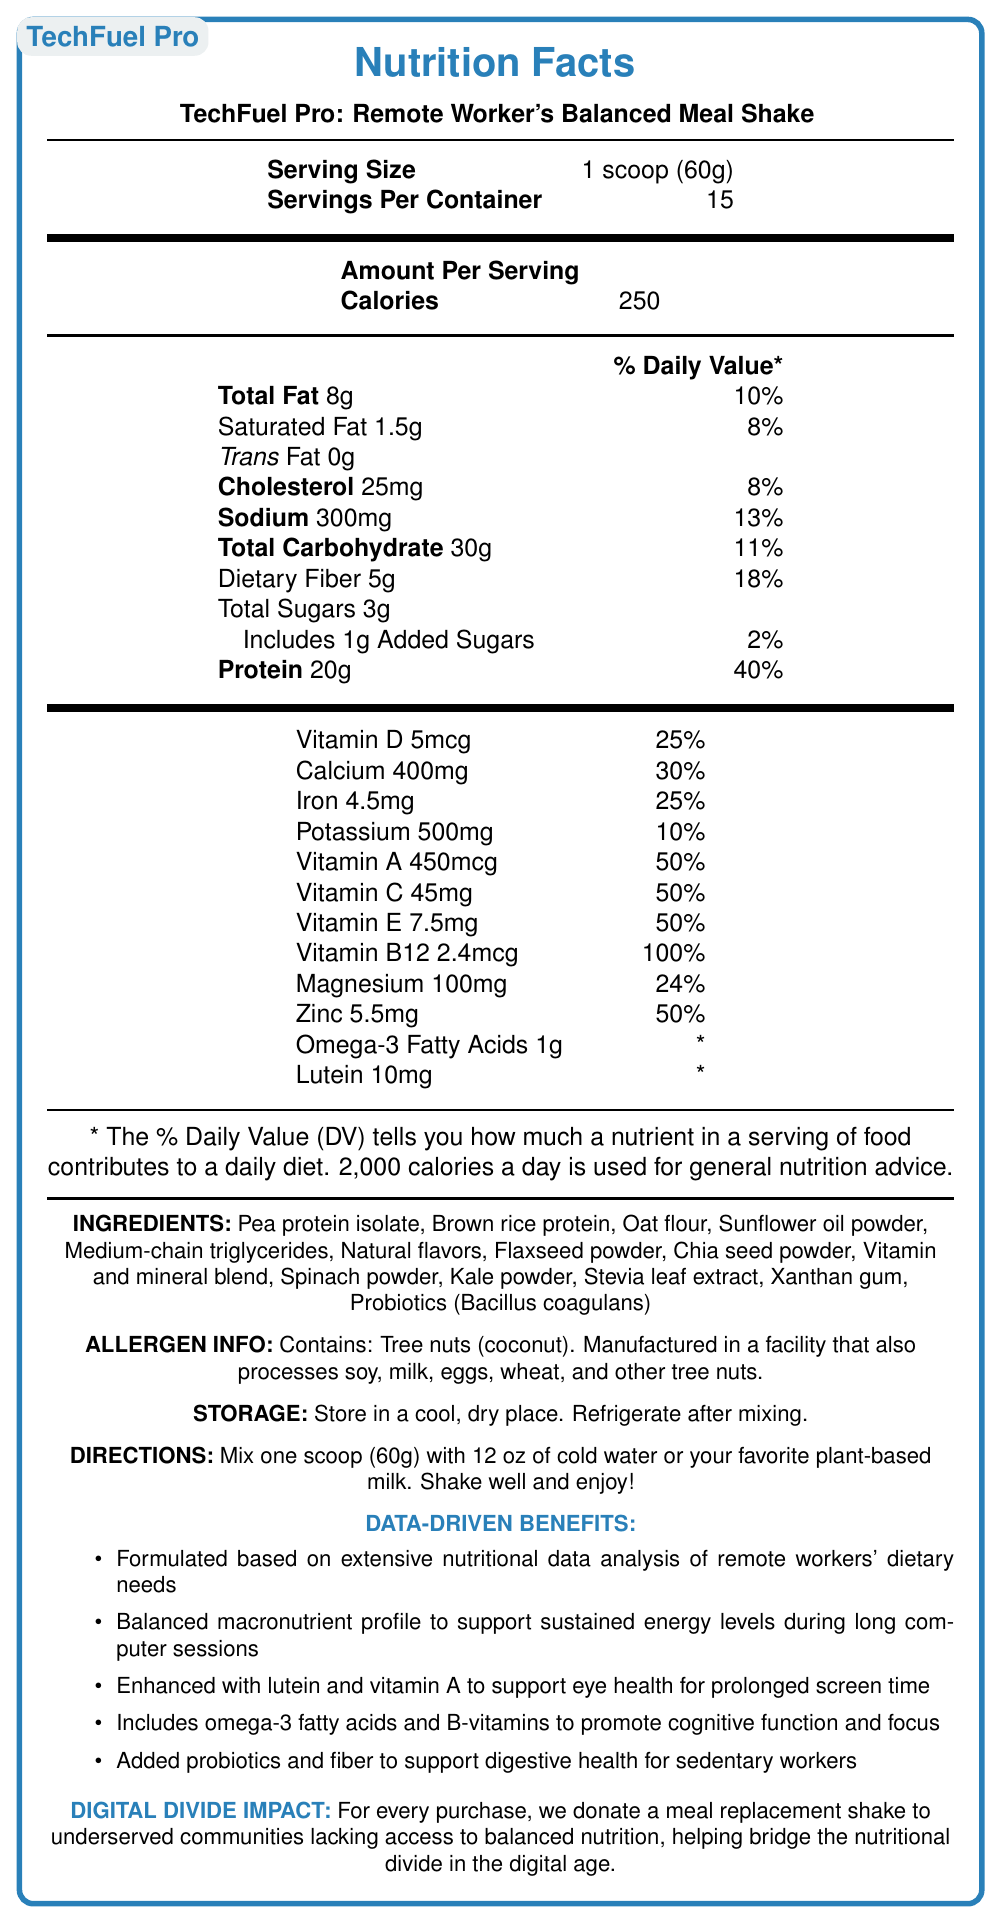what is the serving size? The document explicitly states the serving size as 1 scoop (60g) in the Nutrition Facts section.
Answer: 1 scoop (60g) how many calories per serving? The document lists the number of calories per serving as 250 in the Amount Per Serving section.
Answer: 250 how much protein is in one serving? According to the document, one serving contains 20g of protein and is 40% of the Daily Value.
Answer: 20g what is the percentage of daily value for dietary fiber? The document specifies that the daily value percentage for dietary fiber is 18%.
Answer: 18% which vitamin has the highest percentage of daily value per serving? Vitamin B12 has the highest daily value percentage at 100%, as shown in the document.
Answer: Vitamin B12 (100%) which of the following is not listed as an ingredient in the shake? A. Pea protein, B. Spinach powder, C. Soy protein, D. Kale powder Soy protein is not listed in the ingredients; the document lists Pea protein, Spinach powder, and Kale powder instead.
Answer: C how much added sugar is in one serving? The document states that there is 1g of added sugar in each serving, making up 2% of the Daily Value.
Answer: 1g what is the amount of sodium per serving and its daily value percentage? The document lists sodium as 300mg per serving, accounting for 13% of the daily value.
Answer: 300mg and 13% does the product help in supporting eye health for prolonged screen time? A. True, B. False, C. Not mentioned True, one of the data-driven benefits states that the product is enhanced with lutein and vitamin A to support eye health for prolonged screen time.
Answer: A is this product suitable for someone with a coconut allergy? The document’s allergen information specifies that it contains tree nuts (coconut).
Answer: No summarize the main idea of this document. The document aims to inform about the nutritional values, benefits, ingredients, and impact of the meal replacement shake, tailored to meet remote workers' dietary needs.
Answer: The document provides a detailed Nutrition Facts Label for "TechFuel Pro: Remote Worker's Balanced Meal Shake," emphasizing its balanced nutrient profile designed for remote workers. The label lists the nutritional content, ingredients, allergen information, storage, and preparation instructions. It highlights data-driven benefits like sustained energy, eye health, cognitive function, and digestive health and mentions the product’s impact on bridging the nutritional divide in underserved communities. what is the amount of lutein per serving? The document lists lutein content as 10mg per serving.
Answer: 10mg how many servings are in one container? The document states there are 15 servings per container.
Answer: 15 which vitamin is present at 45mg per serving? The document lists vitamin C content as 45mg per serving.
Answer: Vitamin C who is this product primarily targeted at? A. Athletes, B. Remote workers, C. Children, D. Elderly This product is mainly targeted at remote workers, as indicated by the product name and the description of data-driven benefits for prolonged computer sessions.
Answer: B how much calcium is in one serving and what percentage of the daily value does it represent? The document lists calcium content as 400mg per serving, which is 30% of the daily value.
Answer: 400mg and 30% is this product enhanced with probiotics? The document includes Probiotics (Bacillus coagulans) in the ingredients list.
Answer: Yes what is the main impact of purchasing this product on underserved communities? The document explains that for every purchase, a meal replacement shake is donated to underserved communities lacking access to balanced nutrition.
Answer: Donates a meal replacement shake to underserved communities what is the impact on cognitive function? The data-driven benefits section mentions that omega-3 fatty acids and B-vitamins are included to promote cognitive function and focus.
Answer: Omega-3 fatty acids and B-vitamins promote cognitive function and focus is this product manufactured in a facility that also processes soy? The allergen information notes that the product is manufactured in a facility that also processes soy, among other allergens.
Answer: Yes how many grams of saturated fat are in one serving? The document states that there are 1.5g of saturated fat per serving, accounting for 8% of the daily value.
Answer: 1.5g what storage instructions are provided for the product after mixing? The document indicates that the product should be refrigerated after mixing.
Answer: Refrigerate after mixing can we determine the price of one container from this document? The document does not include any information about the price of one container.
Answer: Cannot be determined what is the claim about dietary fiber and digestive health? The data-driven benefits section claims the product includes added probiotics and fiber to support digestive health for sedentary workers.
Answer: Added probiotics and fiber to support digestive health for sedentary workers 